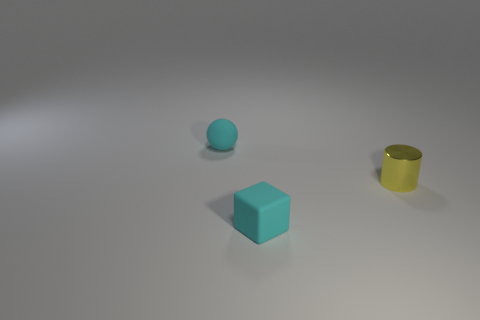Are there more red cubes than yellow cylinders?
Provide a short and direct response. No. Does the sphere have the same material as the block?
Offer a very short reply. Yes. How many small balls have the same material as the yellow thing?
Provide a succinct answer. 0. Do the cylinder and the matte object in front of the metal cylinder have the same size?
Provide a short and direct response. Yes. The tiny thing that is behind the small block and on the left side of the cylinder is what color?
Your answer should be very brief. Cyan. There is a cyan matte thing that is behind the tiny cube; is there a cyan matte thing that is on the right side of it?
Your answer should be very brief. Yes. Are there an equal number of small cyan cubes that are to the right of the yellow metal cylinder and big yellow rubber cylinders?
Your answer should be compact. Yes. There is a tiny cyan matte thing that is in front of the cyan rubber thing that is to the left of the small rubber cube; how many cylinders are left of it?
Provide a short and direct response. 0. Are there any rubber balls of the same size as the rubber block?
Provide a short and direct response. Yes. Is the number of rubber spheres that are left of the cylinder less than the number of tiny cyan spheres?
Keep it short and to the point. No. 